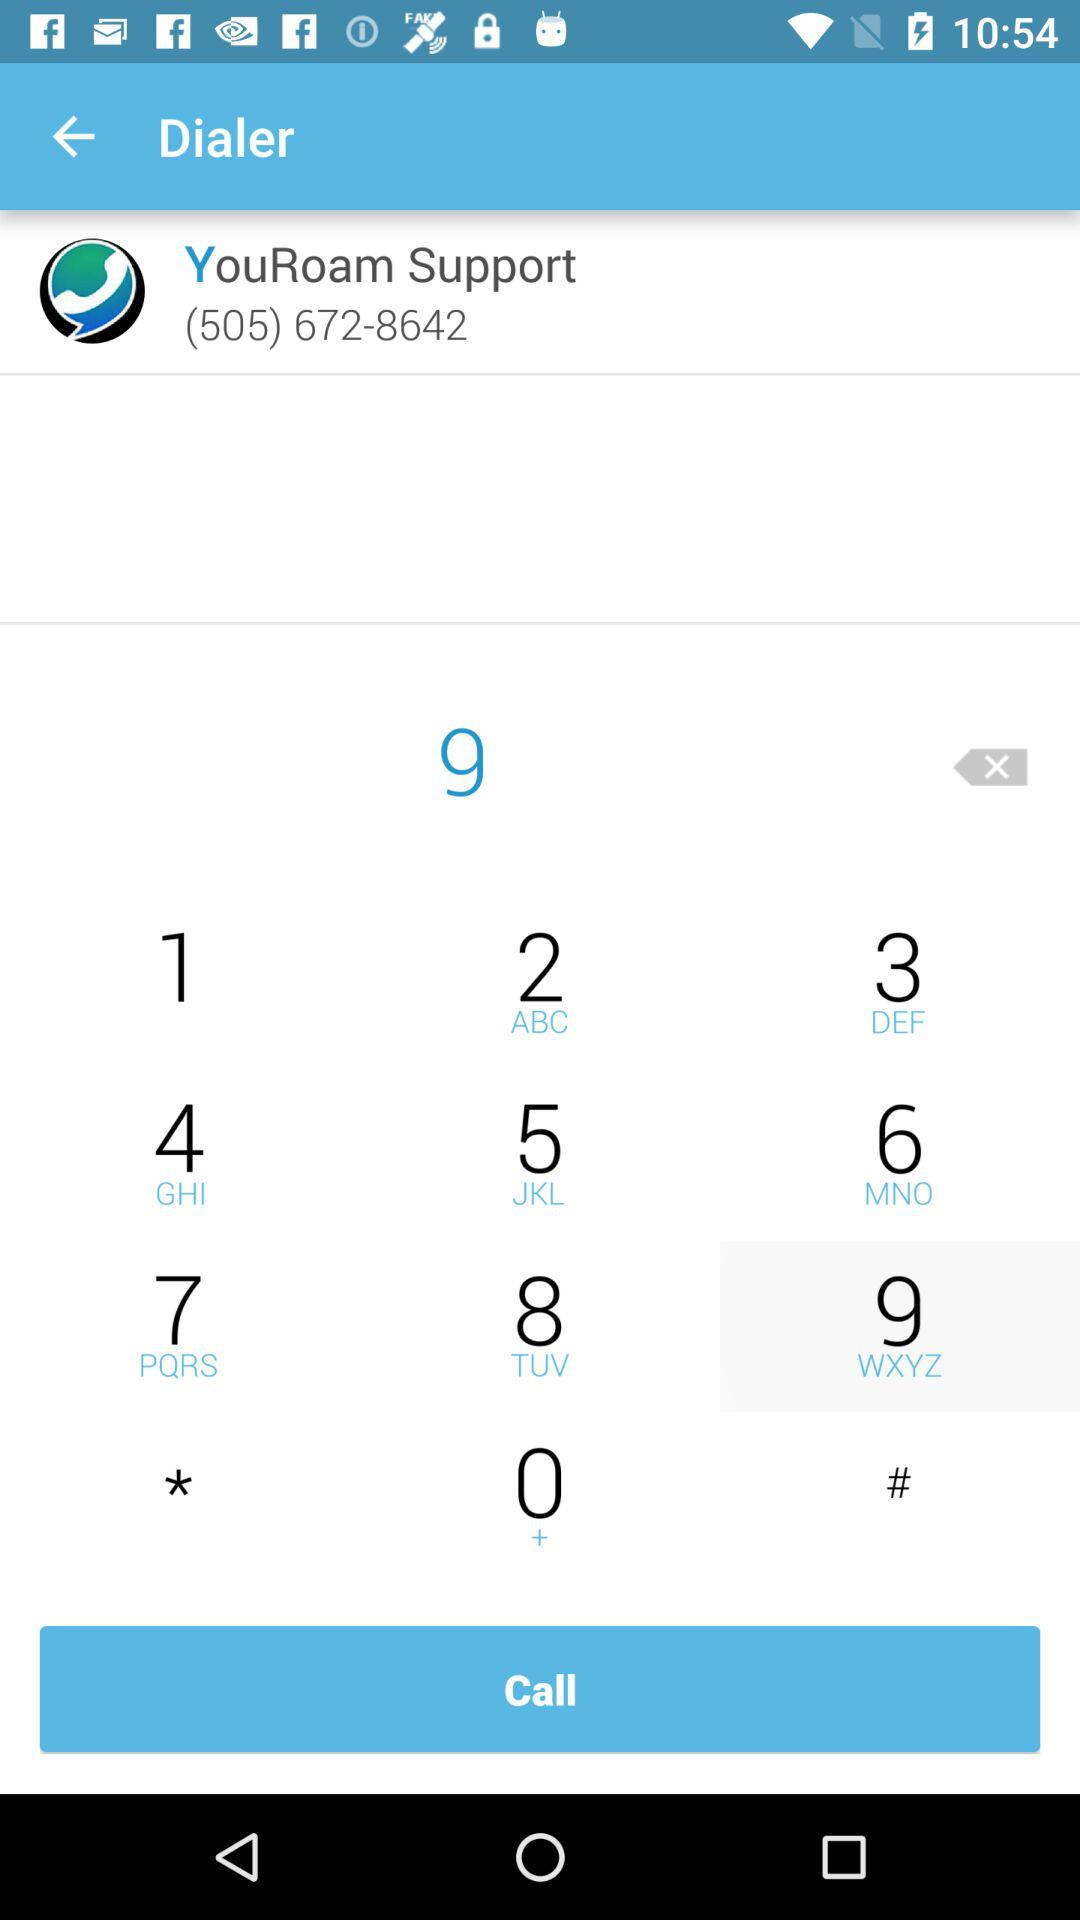What is the selected digit? The selected digit is 9. 